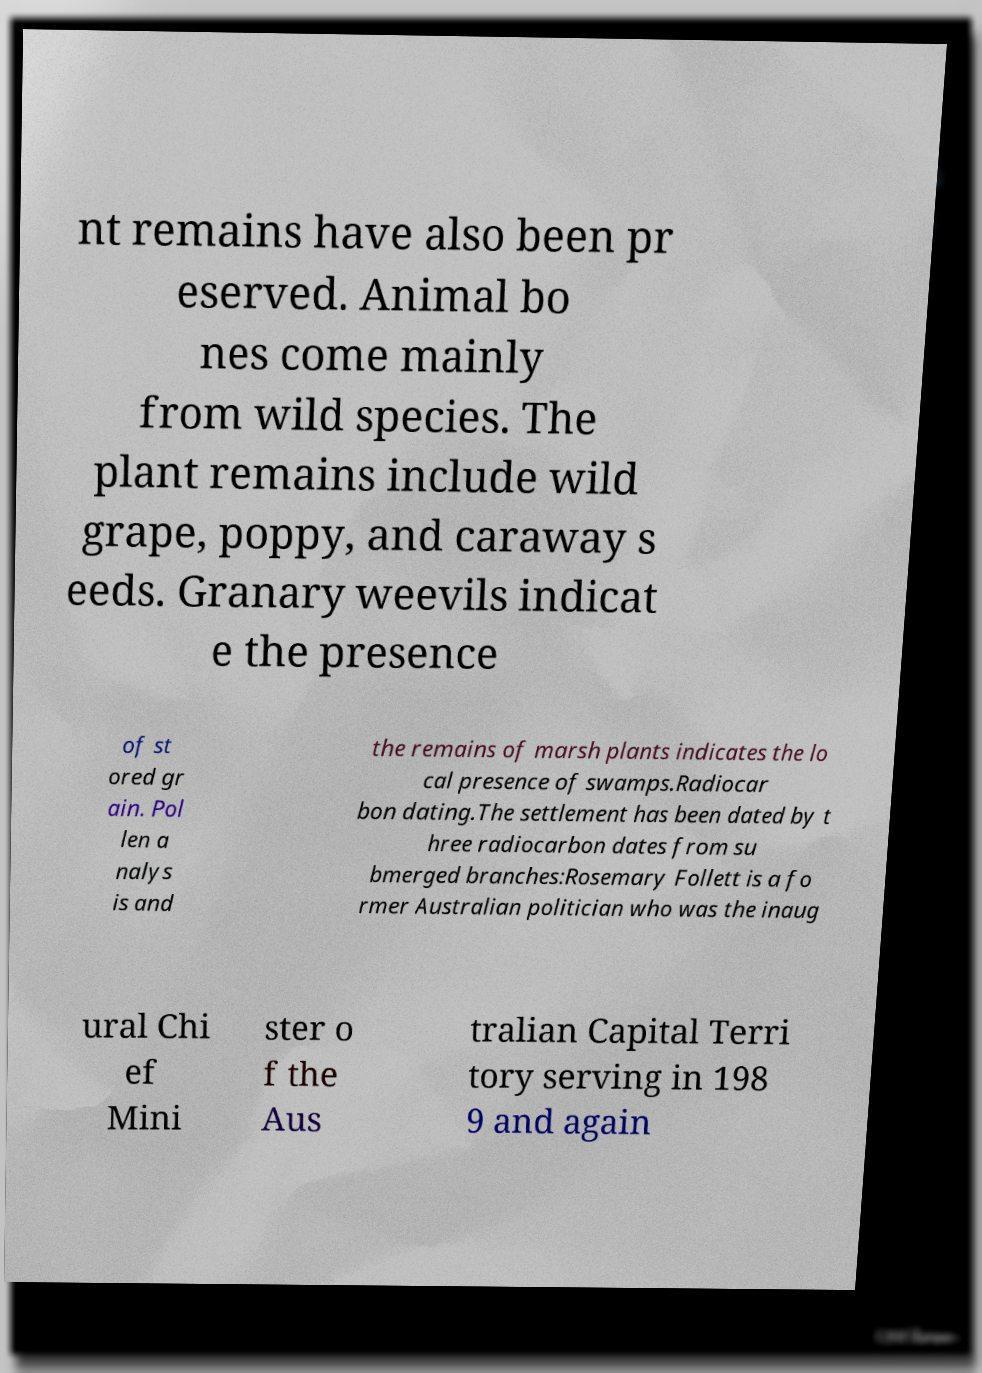I need the written content from this picture converted into text. Can you do that? nt remains have also been pr eserved. Animal bo nes come mainly from wild species. The plant remains include wild grape, poppy, and caraway s eeds. Granary weevils indicat e the presence of st ored gr ain. Pol len a nalys is and the remains of marsh plants indicates the lo cal presence of swamps.Radiocar bon dating.The settlement has been dated by t hree radiocarbon dates from su bmerged branches:Rosemary Follett is a fo rmer Australian politician who was the inaug ural Chi ef Mini ster o f the Aus tralian Capital Terri tory serving in 198 9 and again 